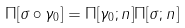Convert formula to latex. <formula><loc_0><loc_0><loc_500><loc_500>\Pi [ \sigma \circ \gamma _ { 0 } ] = \Pi [ \gamma _ { 0 } ; n ] \Pi [ \sigma ; n ]</formula> 